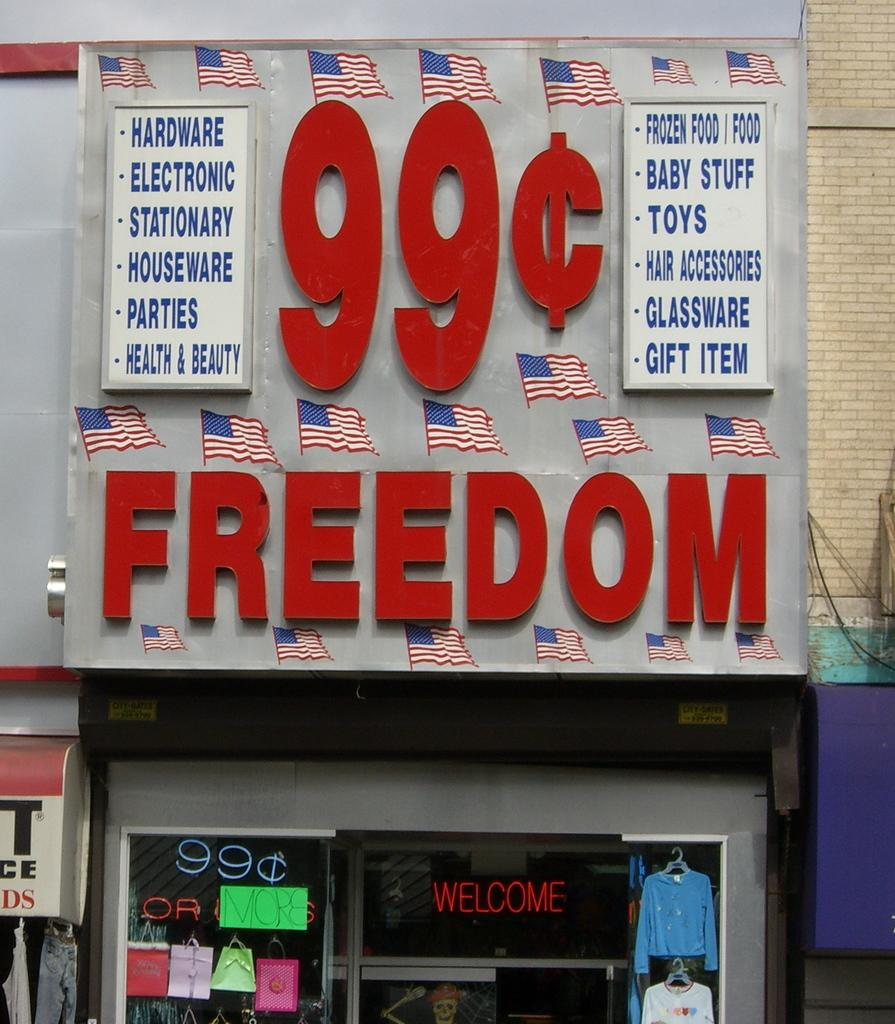What is the main object in the image? There is a board in the image. What is written or displayed on the board? There is text on the board, and there is also a picture of a flag. What type of establishment can be seen in the image? There is a shop visible in the image. What kind of wall is present in the image? There is a brick wall in the image. What type of kettle is used to boil water in the image? There is no kettle present in the image. How does the son contribute to the scene in the image? There is no mention of a son or any person in the image. 